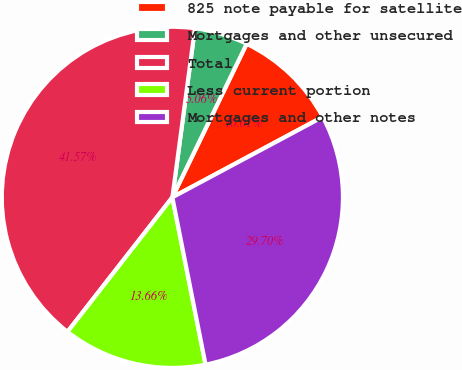Convert chart to OTSL. <chart><loc_0><loc_0><loc_500><loc_500><pie_chart><fcel>825 note payable for satellite<fcel>Mortgages and other unsecured<fcel>Total<fcel>Less current portion<fcel>Mortgages and other notes<nl><fcel>10.01%<fcel>5.06%<fcel>41.57%<fcel>13.66%<fcel>29.7%<nl></chart> 